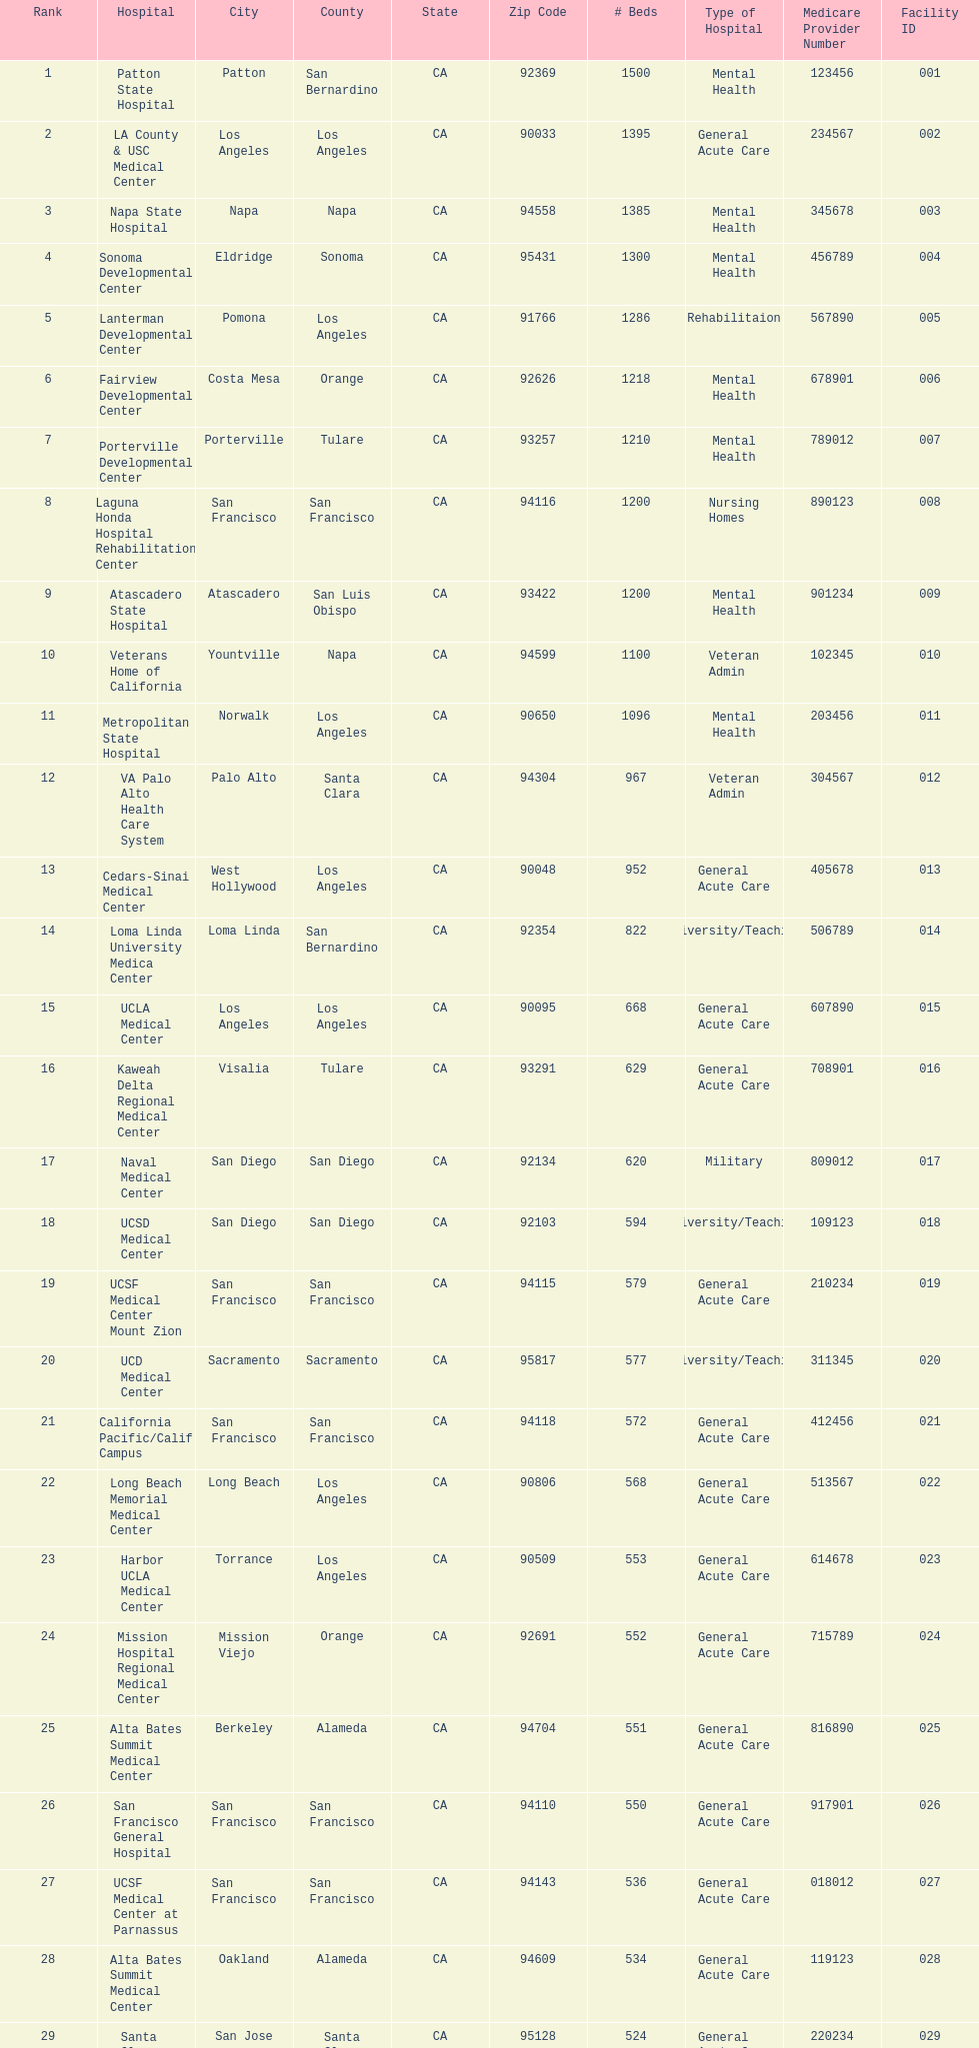What hospital in los angeles county providing hospital beds specifically for rehabilitation is ranked at least among the top 10 hospitals? Lanterman Developmental Center. 